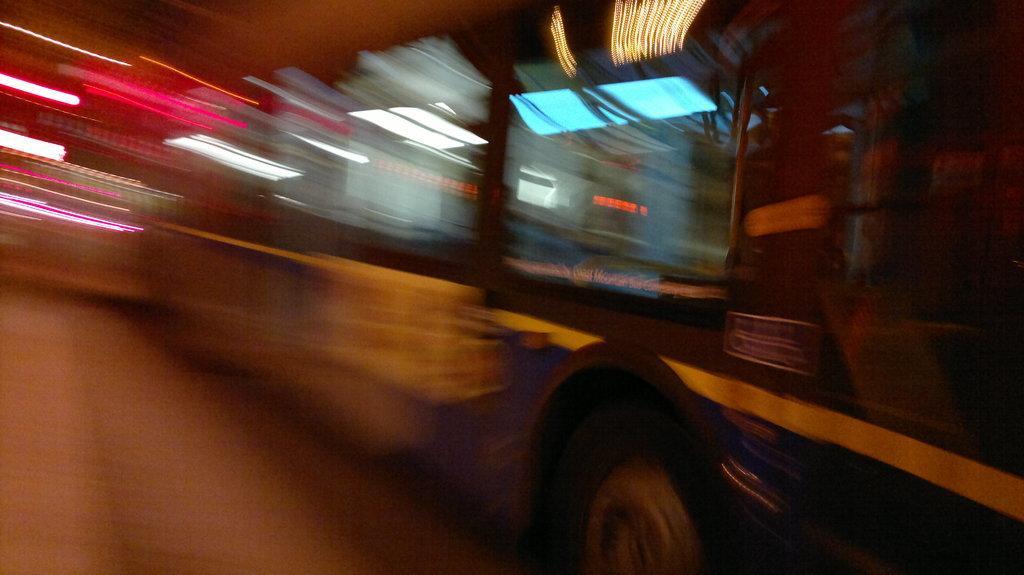In one or two sentences, can you explain what this image depicts? In this image I can see the vehicle. But I can see the image is blurred. 